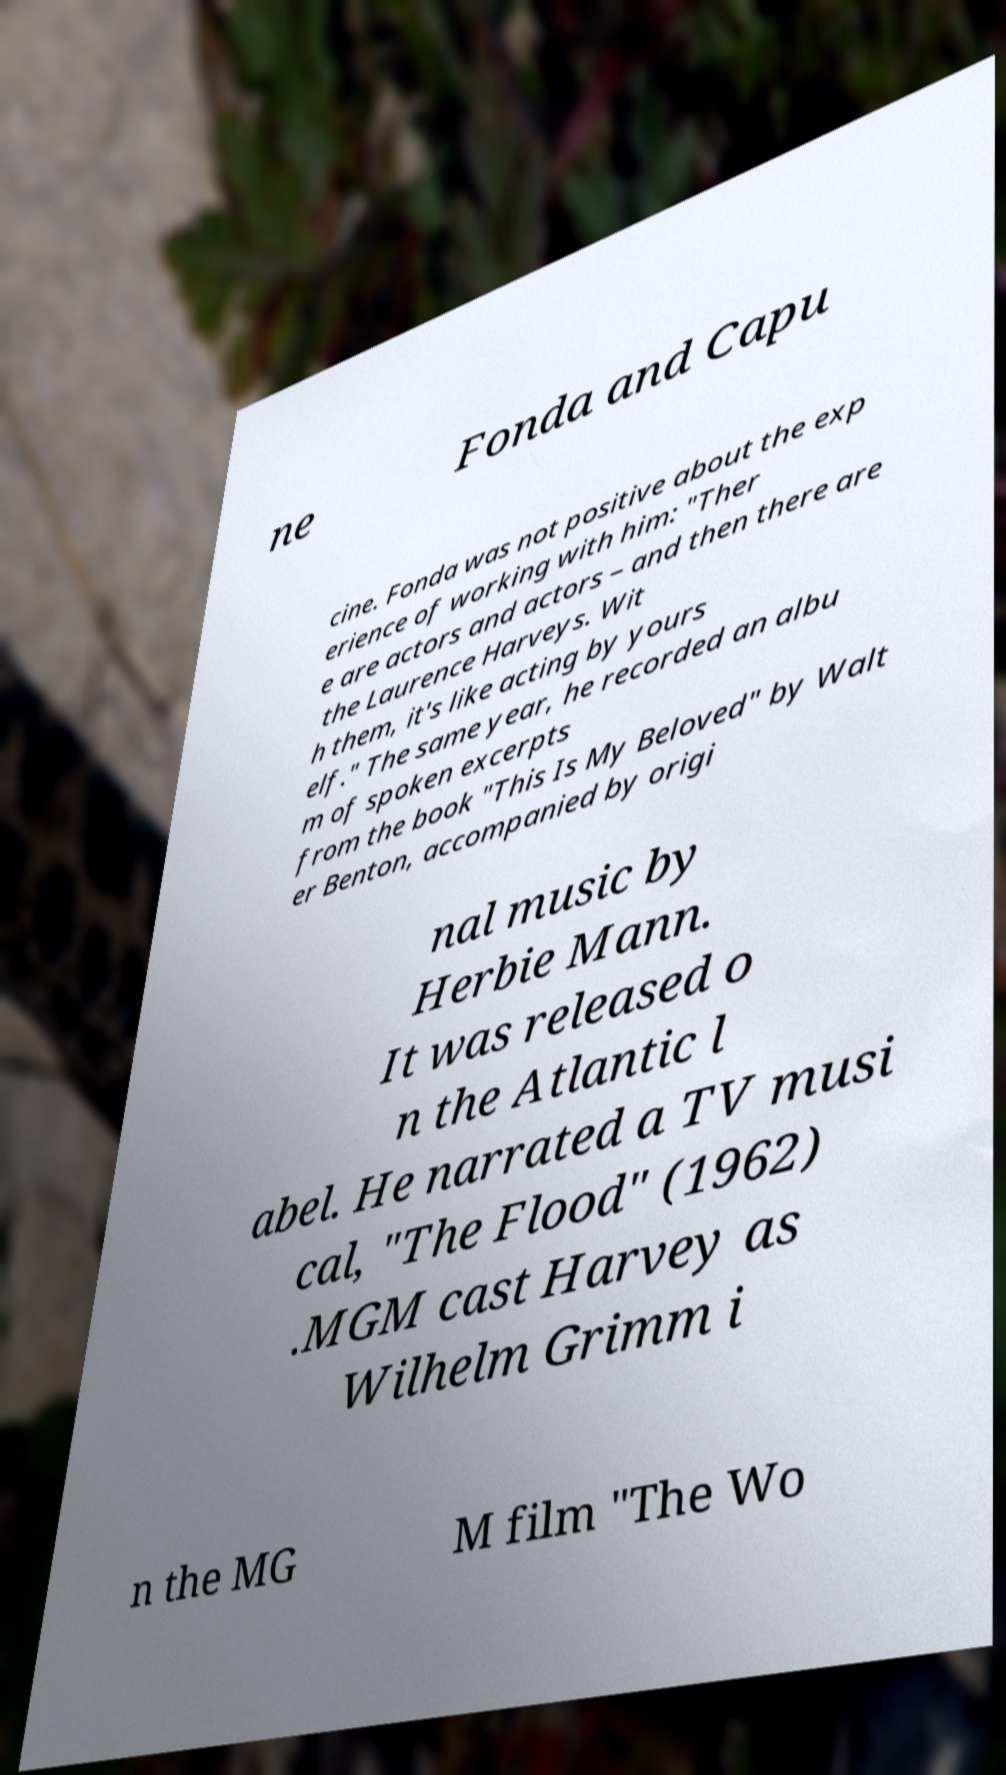Can you read and provide the text displayed in the image?This photo seems to have some interesting text. Can you extract and type it out for me? ne Fonda and Capu cine. Fonda was not positive about the exp erience of working with him: "Ther e are actors and actors – and then there are the Laurence Harveys. Wit h them, it's like acting by yours elf." The same year, he recorded an albu m of spoken excerpts from the book "This Is My Beloved" by Walt er Benton, accompanied by origi nal music by Herbie Mann. It was released o n the Atlantic l abel. He narrated a TV musi cal, "The Flood" (1962) .MGM cast Harvey as Wilhelm Grimm i n the MG M film "The Wo 